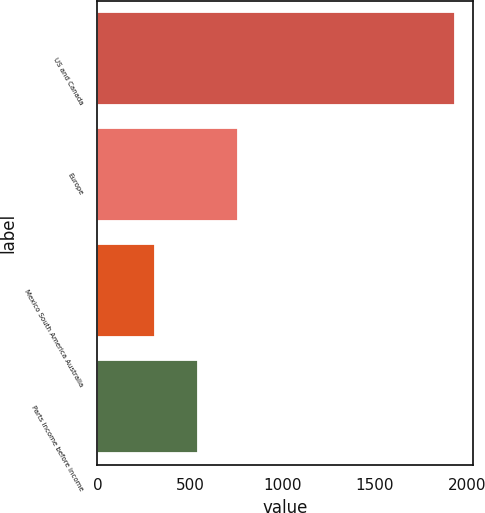Convert chart. <chart><loc_0><loc_0><loc_500><loc_500><bar_chart><fcel>US and Canada<fcel>Europe<fcel>Mexico South America Australia<fcel>Parts income before income<nl><fcel>1932.7<fcel>761.8<fcel>311.2<fcel>543.8<nl></chart> 